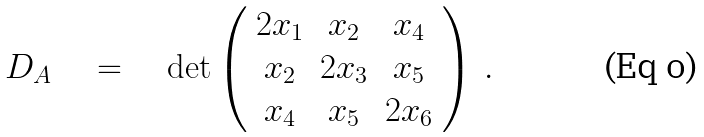Convert formula to latex. <formula><loc_0><loc_0><loc_500><loc_500>D _ { A } \quad = \quad \det \left ( \begin{array} { c c c } 2 x _ { 1 } & x _ { 2 } & x _ { 4 } \\ x _ { 2 } & 2 x _ { 3 } & x _ { 5 } \\ x _ { 4 } & x _ { 5 } & 2 x _ { 6 } \end{array} \right ) \, .</formula> 